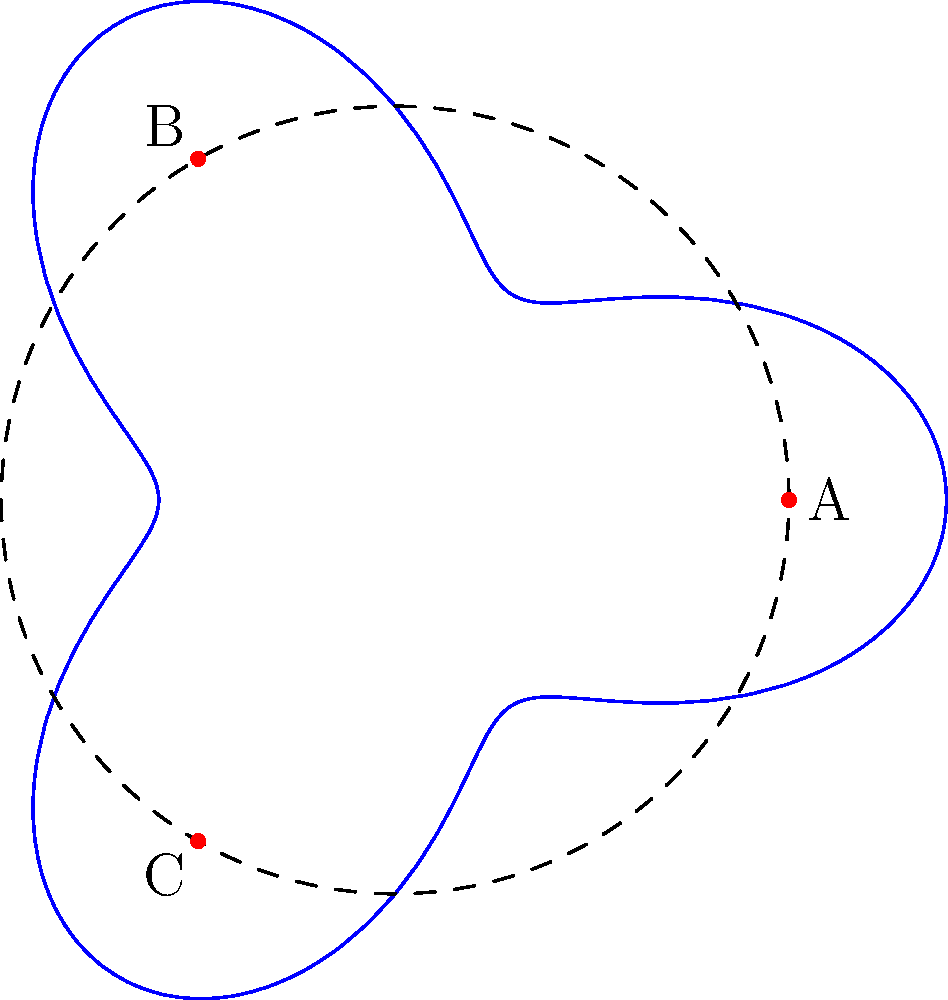The polar graph shown represents the layout of existing utility lines in a community. A new utility line needs to be installed, connecting points A, B, and C. Which path would cause the least disruption to the existing infrastructure?

a) Along the dashed circle
b) Following the blue curve
c) Straight lines connecting A, B, and C
d) A spiral path from the center outwards To determine the optimal placement of the new utility line with minimal disruption, we need to analyze the given polar graph:

1. The blue curve represents the existing utility lines.
2. The dashed circle represents a constant radius of 5 units from the center.
3. Points A, B, and C are marked in red and need to be connected.

Let's consider each option:

a) Along the dashed circle: This would intersect with the existing lines (blue curve) multiple times, causing significant disruption.

b) Following the blue curve: This would require laying the new line directly on top of existing infrastructure, which is impractical and potentially dangerous.

c) Straight lines connecting A, B, and C: This option would minimize intersections with the existing infrastructure. It would cross the blue curve only a few times, reducing disruption.

d) A spiral path from the center outwards: This would intersect with the existing lines multiple times and wouldn't efficiently connect the required points.

The straight-line option (c) provides the most efficient path while minimizing intersections with existing infrastructure. It balances the need for connectivity with the goal of minimal disruption.

As a traditionalist community leader, this solution also aligns with a conservative approach, making minimal changes to the existing layout while addressing the new requirement.
Answer: c) Straight lines connecting A, B, and C 